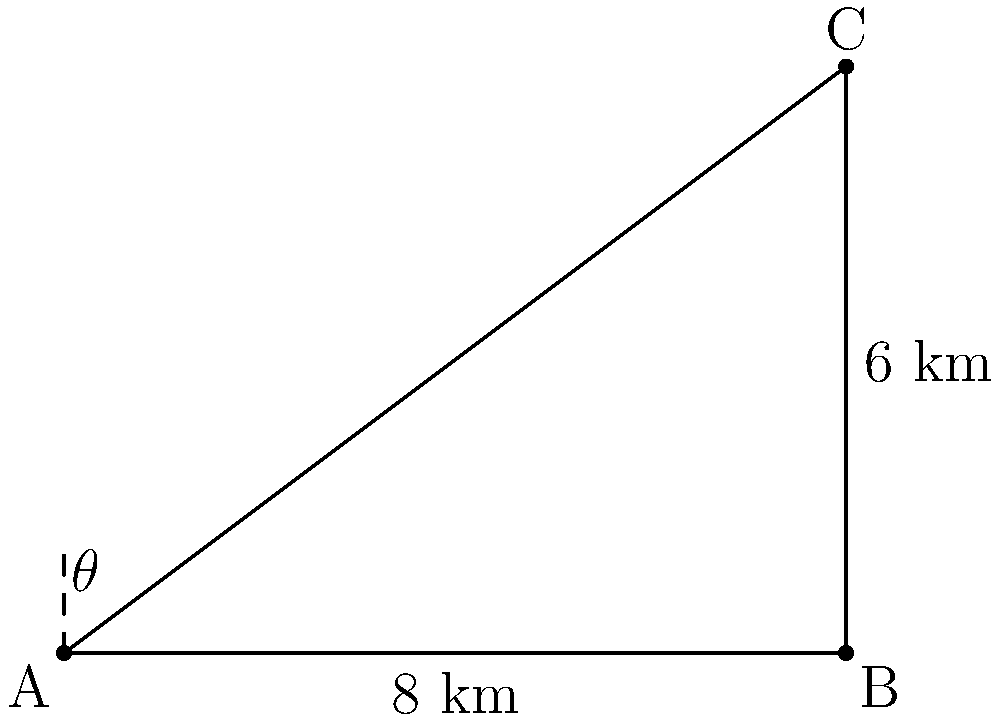In the ancient city of Axum, Ethiopia, there are two historical landmarks: the Church of Our Lady Mary of Zion (point A) and the Obelisk of Axum (point B). From the church, the obelisk is visible 8 km to the east. A third landmark, the Tomb of the False Door (point C), is visible from the obelisk at an angle of elevation of 36.87° from the horizontal. If the distance between the obelisk and the tomb is 6 km, what is the distance between the church and the tomb? Let's approach this step-by-step:

1) We have a right-angled triangle ABC, where:
   - AB is the distance between the church and the obelisk (8 km)
   - BC is the distance between the obelisk and the tomb (6 km)
   - AC is the distance we need to find

2) We know the angle at B is 36.87°. Let's call this angle $\theta$.

3) In the right-angled triangle ABC:
   $\tan \theta = \frac{BC}{AB}$

4) We can verify this:
   $\tan 36.87° \approx \frac{6}{8} = 0.75$

5) To find AC, we can use the Pythagorean theorem:
   $AC^2 = AB^2 + BC^2$

6) Substituting the known values:
   $AC^2 = 8^2 + 6^2 = 64 + 36 = 100$

7) Taking the square root of both sides:
   $AC = \sqrt{100} = 10$

Therefore, the distance between the Church of Our Lady Mary of Zion and the Tomb of the False Door is 10 km.
Answer: 10 km 